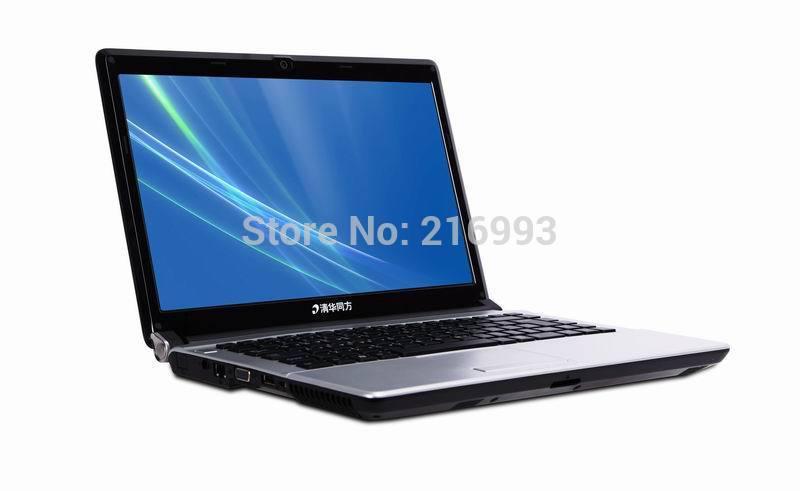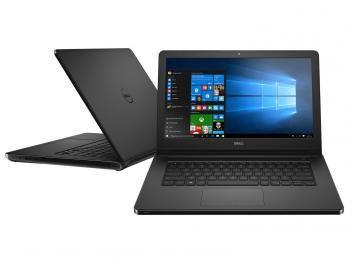The first image is the image on the left, the second image is the image on the right. For the images displayed, is the sentence "At least one computer has a blue graphic background on the screen." factually correct? Answer yes or no. Yes. 